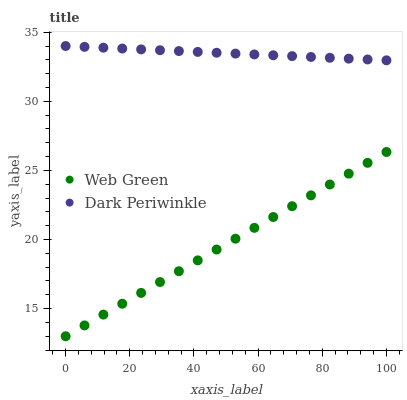Does Web Green have the minimum area under the curve?
Answer yes or no. Yes. Does Dark Periwinkle have the maximum area under the curve?
Answer yes or no. Yes. Does Web Green have the maximum area under the curve?
Answer yes or no. No. Is Dark Periwinkle the smoothest?
Answer yes or no. Yes. Is Web Green the roughest?
Answer yes or no. Yes. Is Web Green the smoothest?
Answer yes or no. No. Does Web Green have the lowest value?
Answer yes or no. Yes. Does Dark Periwinkle have the highest value?
Answer yes or no. Yes. Does Web Green have the highest value?
Answer yes or no. No. Is Web Green less than Dark Periwinkle?
Answer yes or no. Yes. Is Dark Periwinkle greater than Web Green?
Answer yes or no. Yes. Does Web Green intersect Dark Periwinkle?
Answer yes or no. No. 